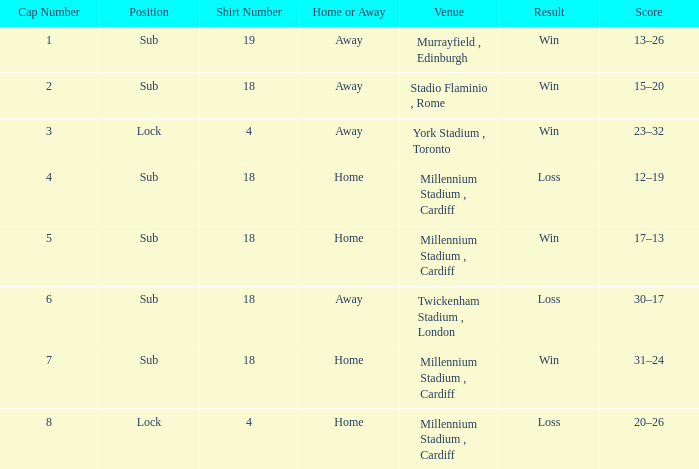Can you provide the winning score from the match that took place on november 13, 2009? 17–13. 